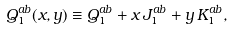Convert formula to latex. <formula><loc_0><loc_0><loc_500><loc_500>Q _ { 1 } ^ { a b } ( x , y ) \equiv Q _ { 1 } ^ { a b } + x \, J _ { 1 } ^ { a b } + y \, K _ { 1 } ^ { a b } ,</formula> 